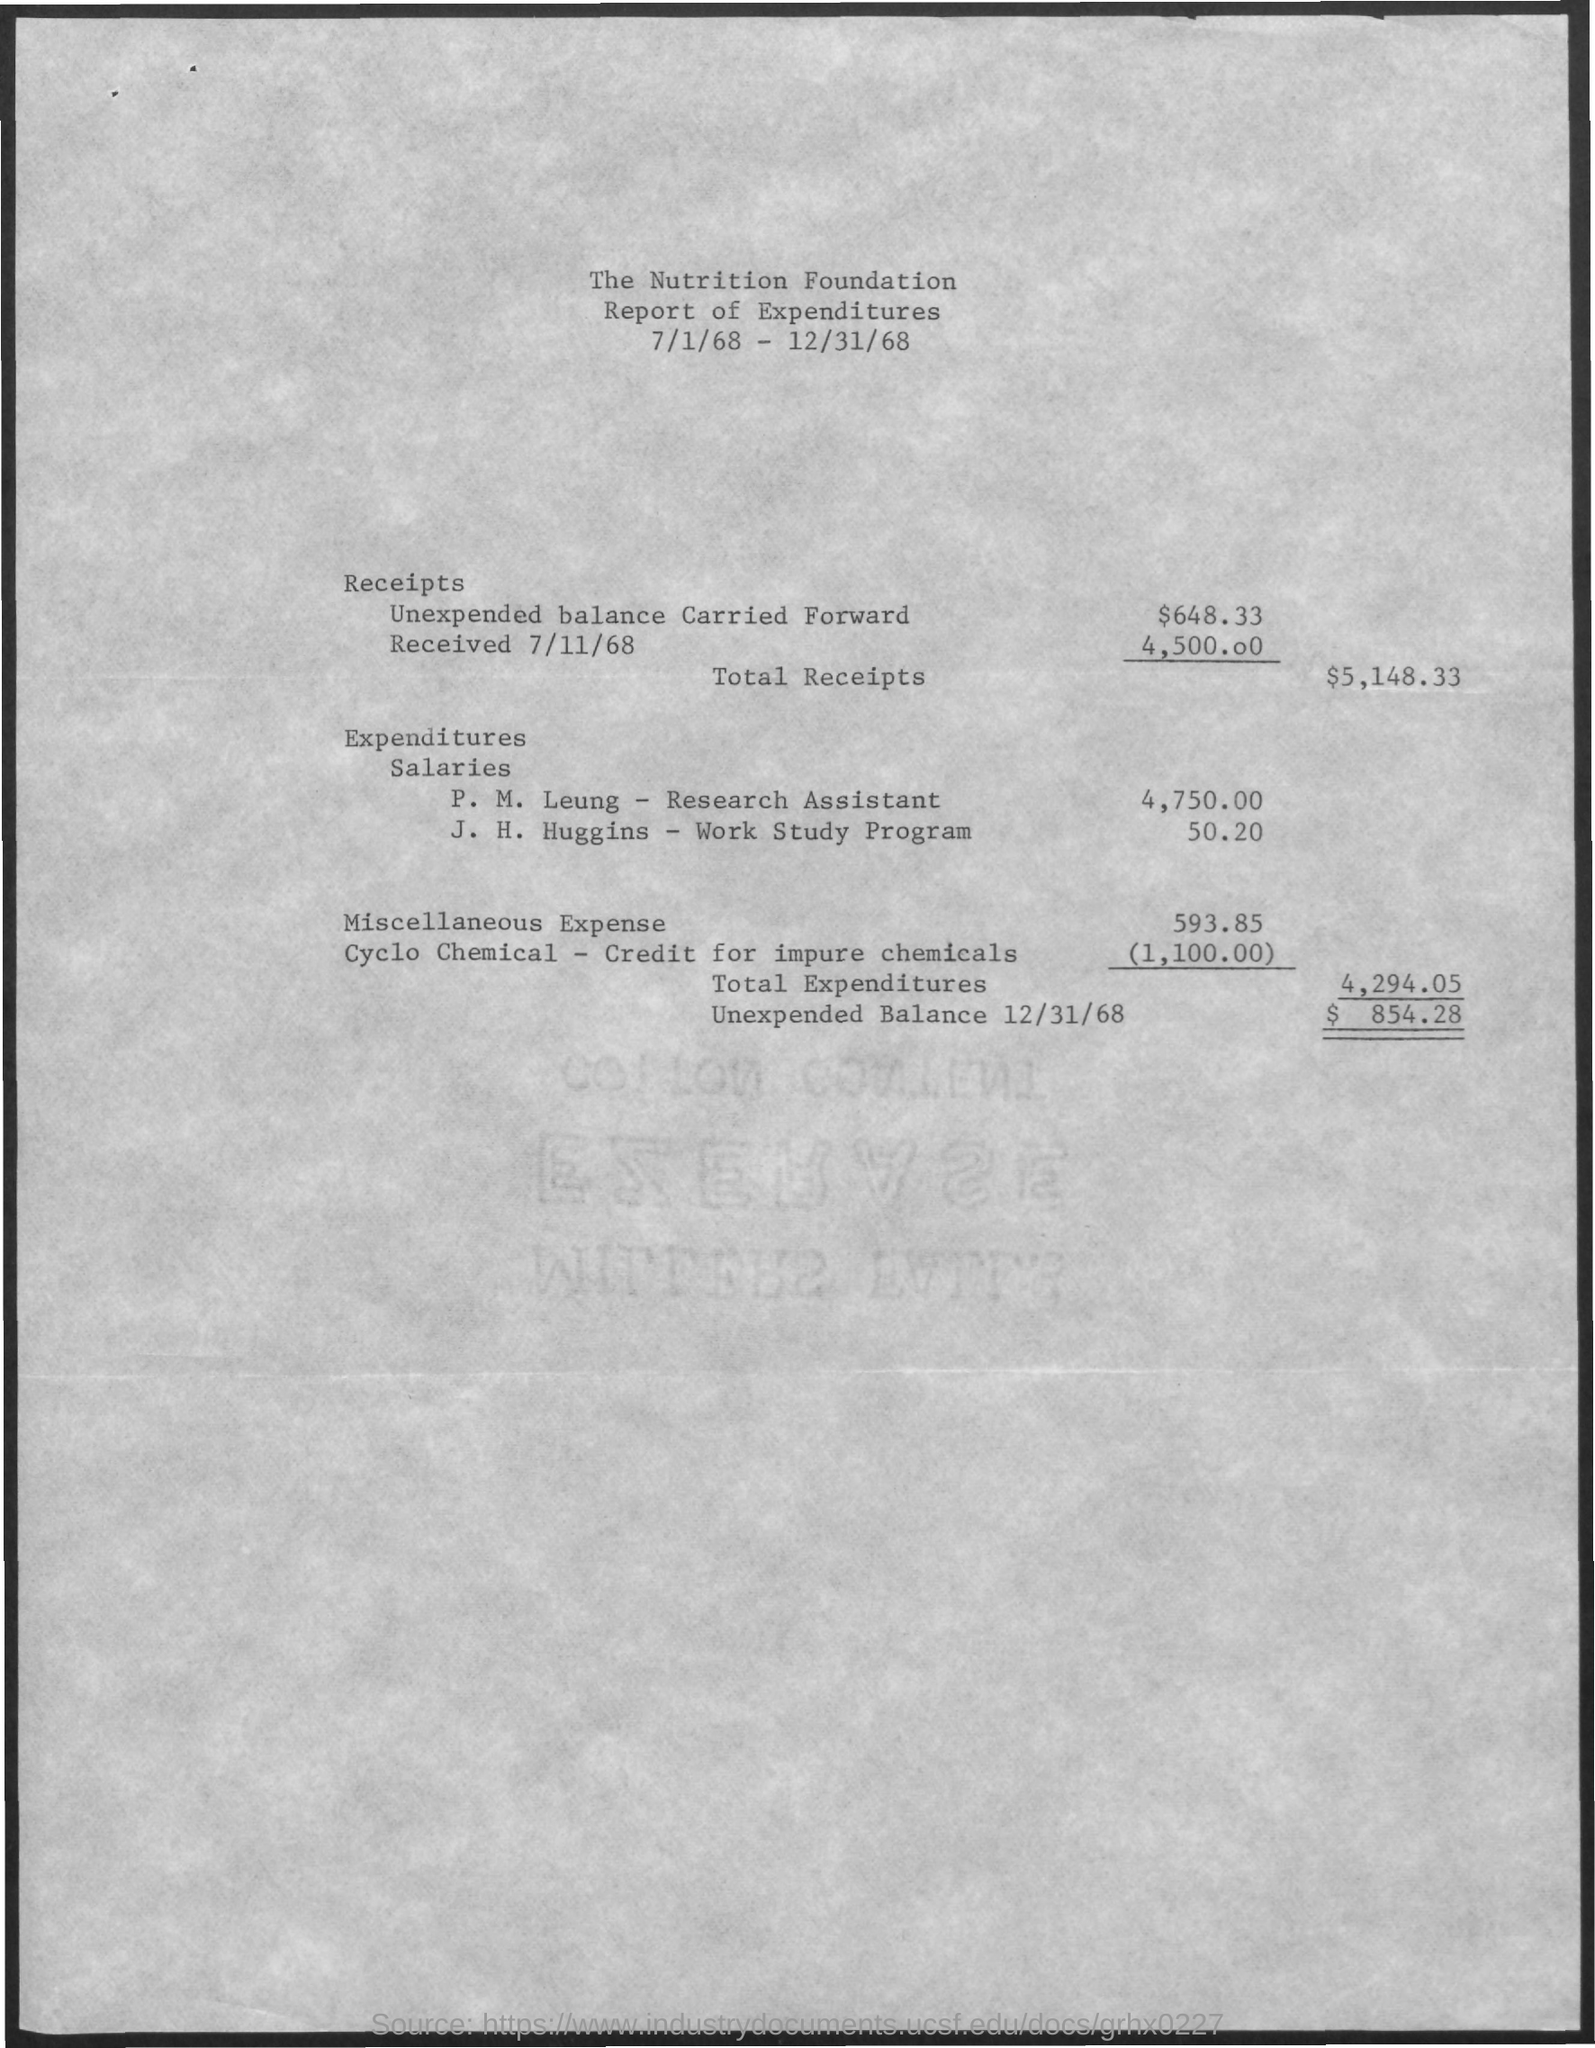What is the amount of unexpended balance carried forward  as shown in the report ?
Keep it short and to the point. $ 648.33. How much amount is received by 7/11/68 as shown in the report ?
Offer a terse response. 4,500.00. What is the amount of total receipts mentioned in the given report ?
Ensure brevity in your answer.  $5,148.33. What is the salary given to p.m.leung - research assistant ?
Give a very brief answer. 4,750.00. What is the salary givenn to j.h.huggins -work study program ?
Your answer should be very brief. 50.20. What is the amount of miscellaneous expense mentioned in the given report ?
Provide a succinct answer. 593.85. What is the unexpended balance on 12/31/68 as shown in the report ?
Your answer should be compact. $ 854.28. 